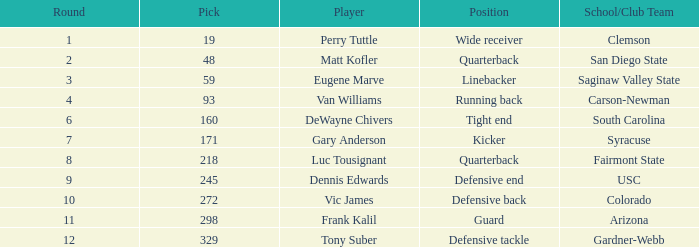Who is the person playing as a linebacker? Eugene Marve. 